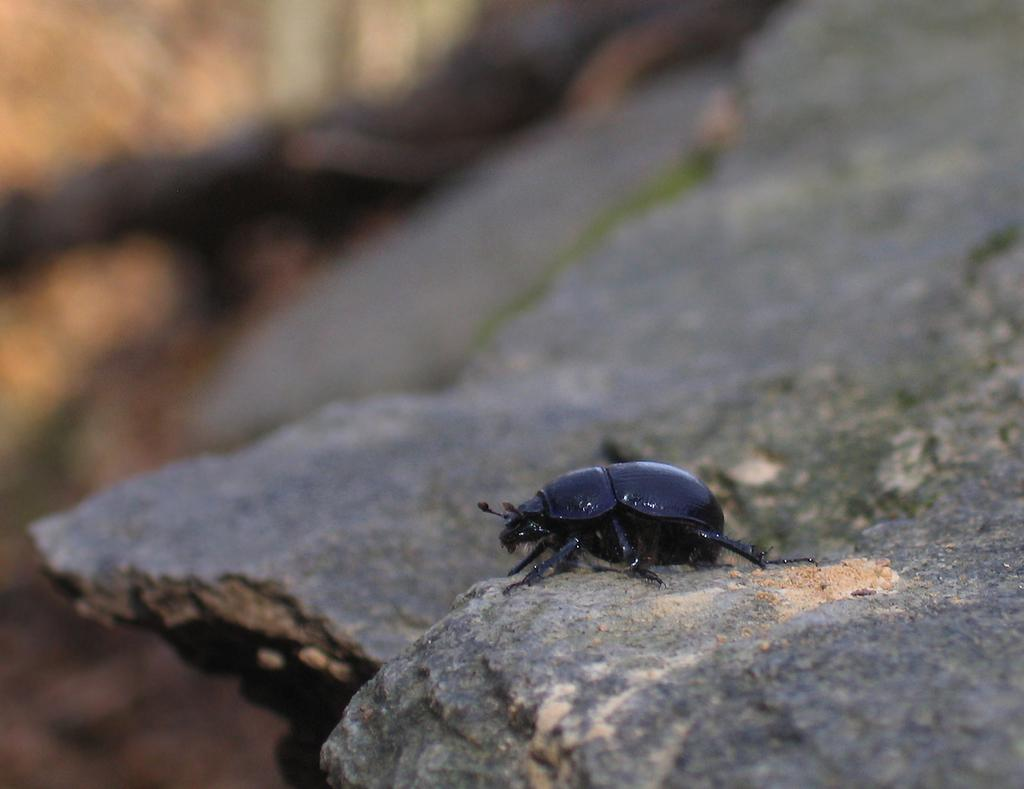What is the main subject of the image? The main subject of the image is a rock. What is on the rock? There is sand on the rock, and there is also an insect on the rock. How would you describe the background of the image? The background of the image is blurred. What type of eggnog can be seen in the image? There is no eggnog present in the image. What is the laborer doing in the image? There is no laborer present in the image. 